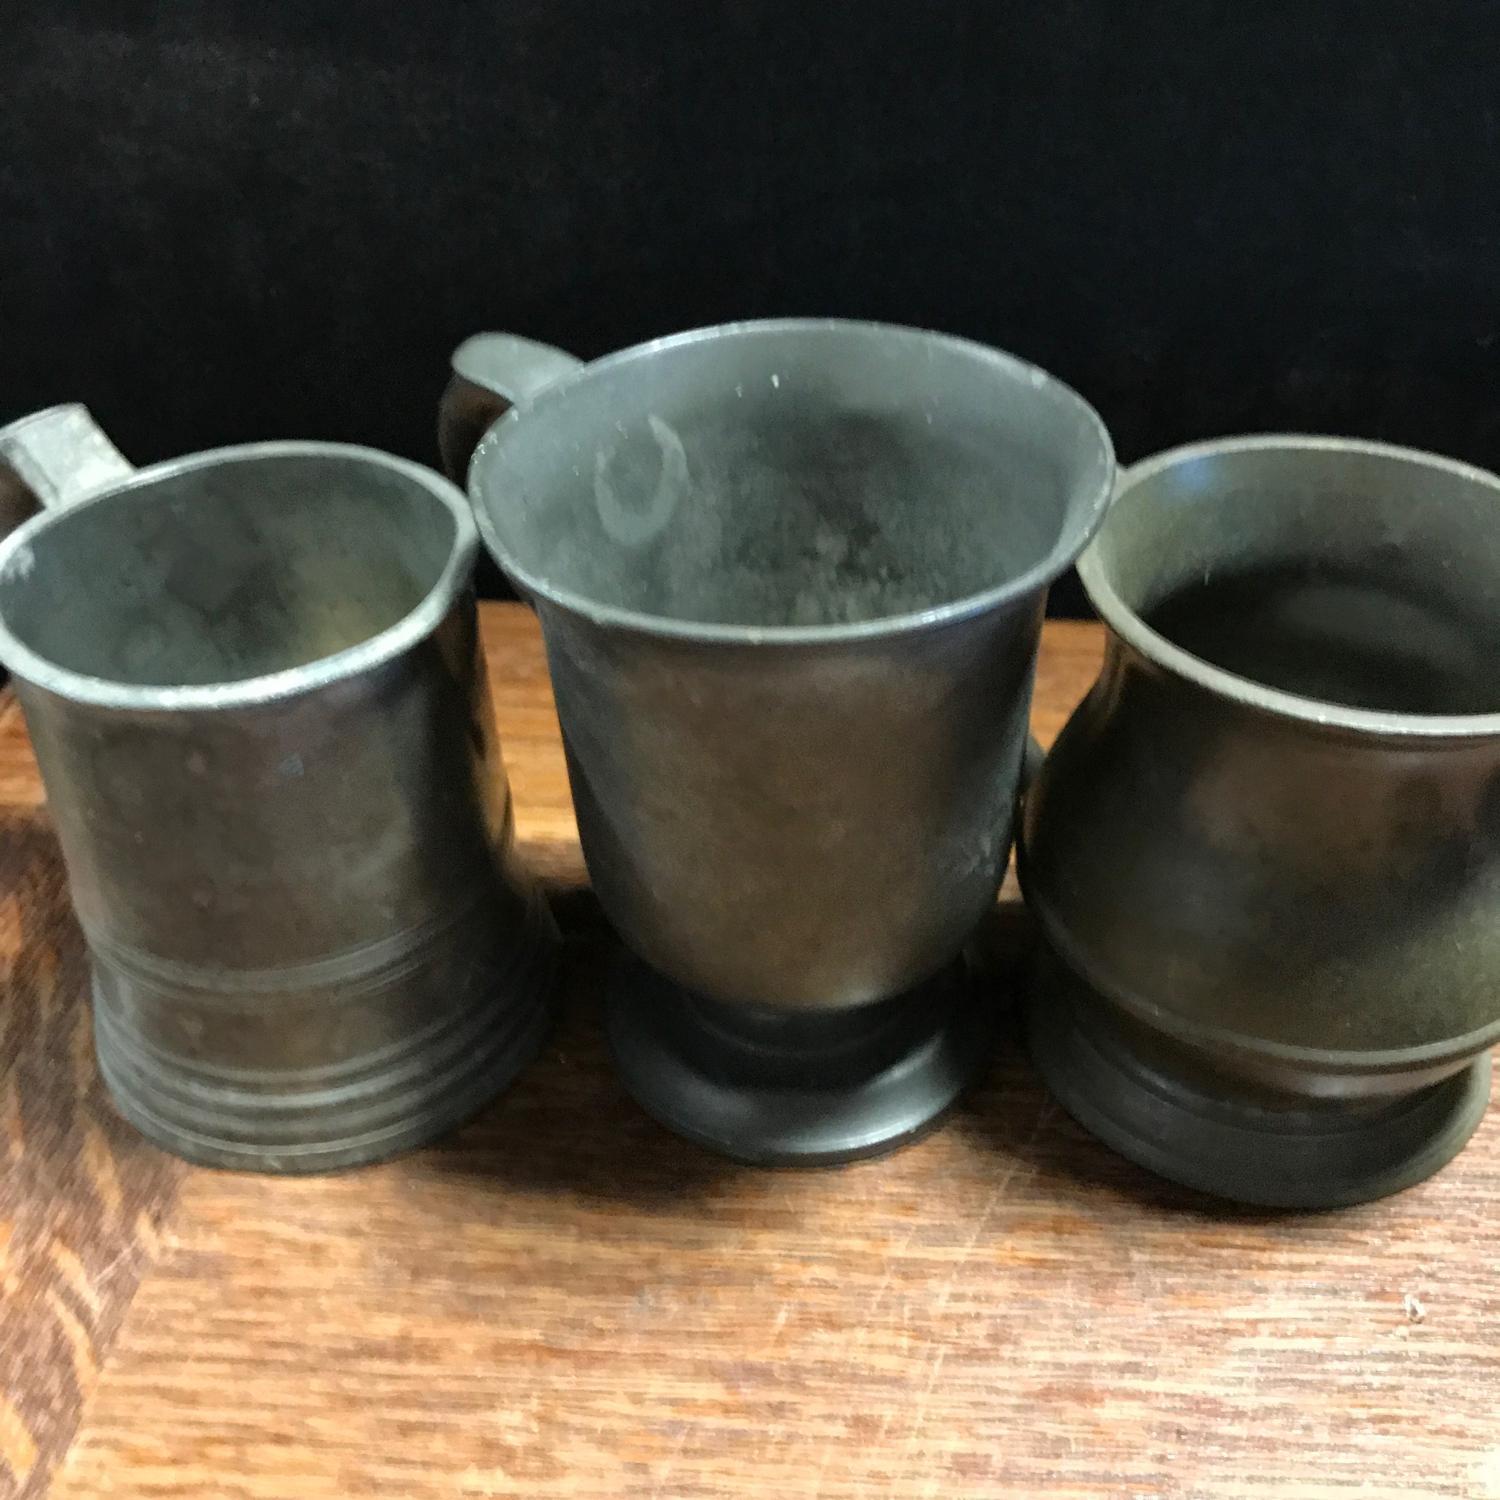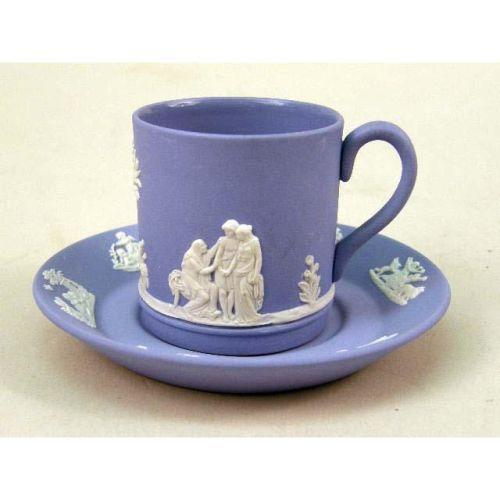The first image is the image on the left, the second image is the image on the right. Evaluate the accuracy of this statement regarding the images: "The image on the left shows three greenish mugs on a wooden table.". Is it true? Answer yes or no. Yes. The first image is the image on the left, the second image is the image on the right. Evaluate the accuracy of this statement regarding the images: "There are exactly 6 cups, and no other objects.". Is it true? Answer yes or no. No. 